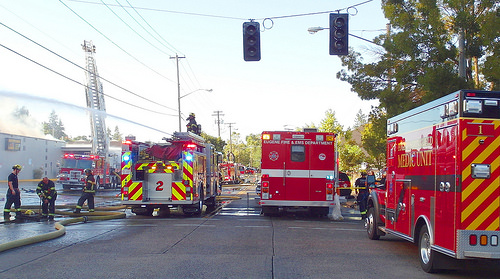<image>
Can you confirm if the fireman is on the water? No. The fireman is not positioned on the water. They may be near each other, but the fireman is not supported by or resting on top of the water. Is the truck behind the truck? Yes. From this viewpoint, the truck is positioned behind the truck, with the truck partially or fully occluding the truck. Is the light above the truck? No. The light is not positioned above the truck. The vertical arrangement shows a different relationship. 